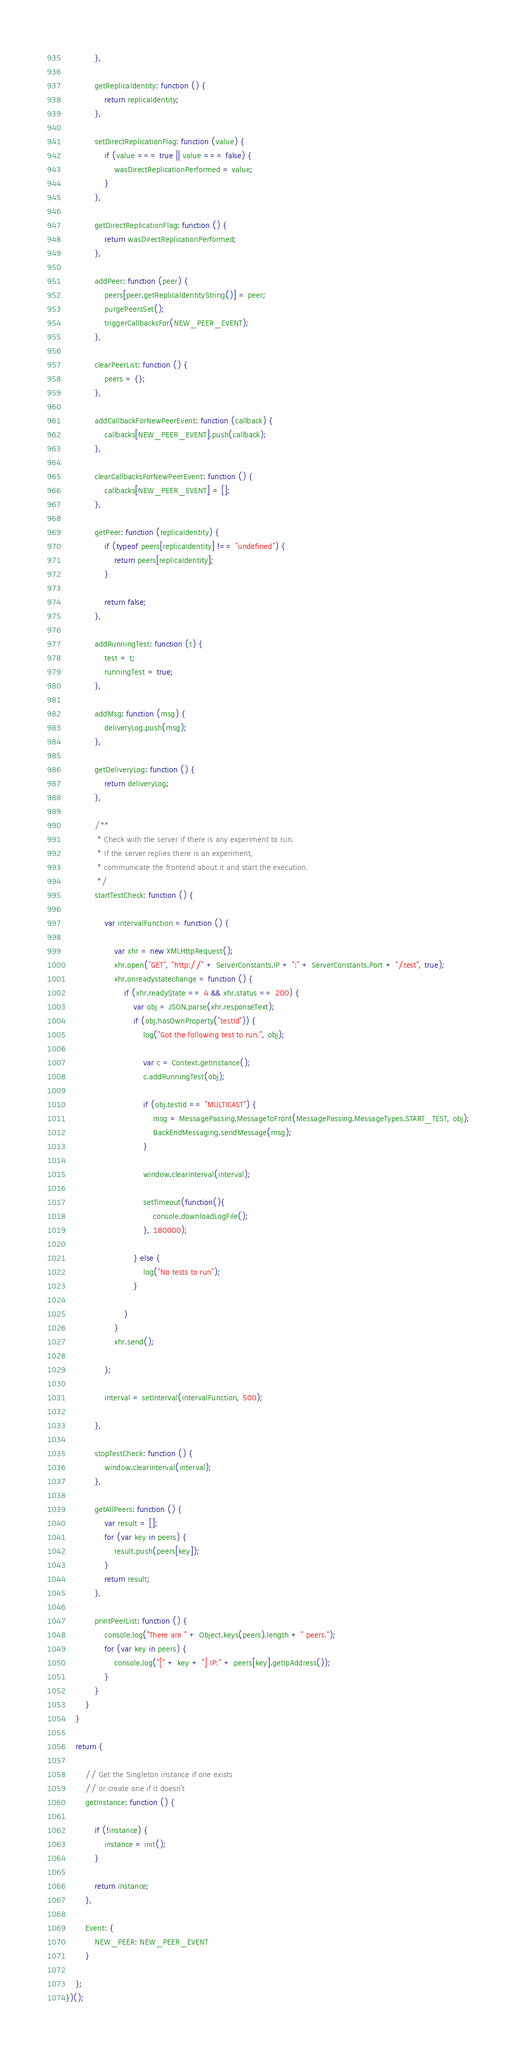<code> <loc_0><loc_0><loc_500><loc_500><_JavaScript_>            },

            getReplicaIdentity: function () {
                return replicaIdentity;
            },

            setDirectReplicationFlag: function (value) {
                if (value === true || value === false) {
                    wasDirectReplicationPerformed = value;
                }
            },

            getDirectReplicationFlag: function () {
                return wasDirectReplicationPerformed;
            },

            addPeer: function (peer) {
                peers[peer.getReplicaIdentityString()] = peer;
                purgePeersSet();
                triggerCallbacksFor(NEW_PEER_EVENT);
            },

            clearPeerList: function () {
                peers = {};
            },

            addCallbackForNewPeerEvent: function (callback) {
                callbacks[NEW_PEER_EVENT].push(callback);
            },

            clearCallbacksForNewPeerEvent: function () {
                callbacks[NEW_PEER_EVENT] = [];
            },

            getPeer: function (replicaIdentity) {
                if (typeof peers[replicaIdentity] !== "undefined") {
                    return peers[replicaIdentity];
                }

                return false;
            },

            addRunningTest: function (t) {
                test = t;
                runningTest = true;
            },

            addMsg: function (msg) {
                deliveryLog.push(msg);
            },

            getDeliveryLog: function () {
                return deliveryLog;
            },

            /**
             * Check with the server if there is any experiment to run.
             * If the server replies there is an experiment,
             * communicate the frontend about it and start the execution.
             */
            startTestCheck: function () {

                var intervalFunction = function () {

                    var xhr = new XMLHttpRequest();
                    xhr.open("GET", "http://" + ServerConstants.IP + ":" + ServerConstants.Port + "/test", true);
                    xhr.onreadystatechange = function () {
                        if (xhr.readyState == 4 && xhr.status == 200) {
                            var obj = JSON.parse(xhr.responseText);
                            if (obj.hasOwnProperty("testId")) {
                                log("Got the following test to run.", obj);

                                var c = Context.getInstance();
                                c.addRunningTest(obj);

                                if (obj.testId == "MULTICAST") {
                                    msg = MessagePassing.MessageToFront(MessagePassing.MessageTypes.START_TEST, obj);
                                    BackEndMessaging.sendMessage(msg);
                                }

                                window.clearInterval(interval);

                                setTimeout(function(){
                                    console.downloadLogFile();
                                }, 180000);

                            } else {
                                log("No tests to run");
                            }

                        }
                    }
                    xhr.send();

                };

                interval = setInterval(intervalFunction, 500);

            },

            stopTestCheck: function () {
                window.clearInterval(interval);
            },

            getAllPeers: function () {
                var result = [];
                for (var key in peers) {
                    result.push(peers[key]);
                }
                return result;
            },

            printPeerList: function () {
                console.log("There are " + Object.keys(peers).length + " peers.");
                for (var key in peers) {
                    console.log("[" + key + "] IP:" + peers[key].getIpAddress());
                }
            }
        }
    }

    return {

        // Get the Singleton instance if one exists
        // or create one if it doesn't
        getInstance: function () {

            if (!instance) {
                instance = init();
            }

            return instance;
        },

        Event: {
            NEW_PEER: NEW_PEER_EVENT
        }

    };
})();
</code> 